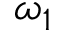<formula> <loc_0><loc_0><loc_500><loc_500>\omega _ { 1 }</formula> 